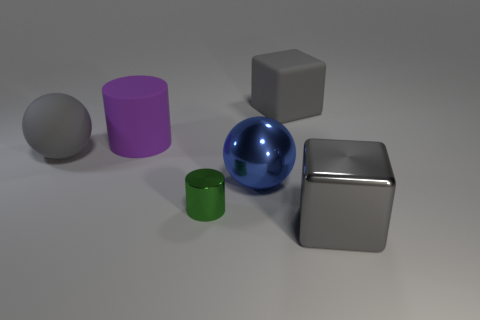What material is the blue object that is the same size as the gray matte ball?
Offer a very short reply. Metal. What number of other objects are there of the same material as the blue thing?
Make the answer very short. 2. What number of large blocks are behind the big purple cylinder?
Provide a short and direct response. 1. What number of cylinders are cyan metal things or large blue metal things?
Provide a succinct answer. 0. How big is the object that is both behind the large gray ball and on the left side of the large shiny ball?
Give a very brief answer. Large. What number of other things are the same color as the metal sphere?
Your answer should be compact. 0. Are the big blue sphere and the block in front of the green cylinder made of the same material?
Offer a very short reply. Yes. How many things are either blocks in front of the purple rubber cylinder or blue objects?
Keep it short and to the point. 2. What shape is the matte object that is on the left side of the big blue metallic object and behind the matte sphere?
Give a very brief answer. Cylinder. Is there anything else that is the same size as the green cylinder?
Provide a short and direct response. No. 